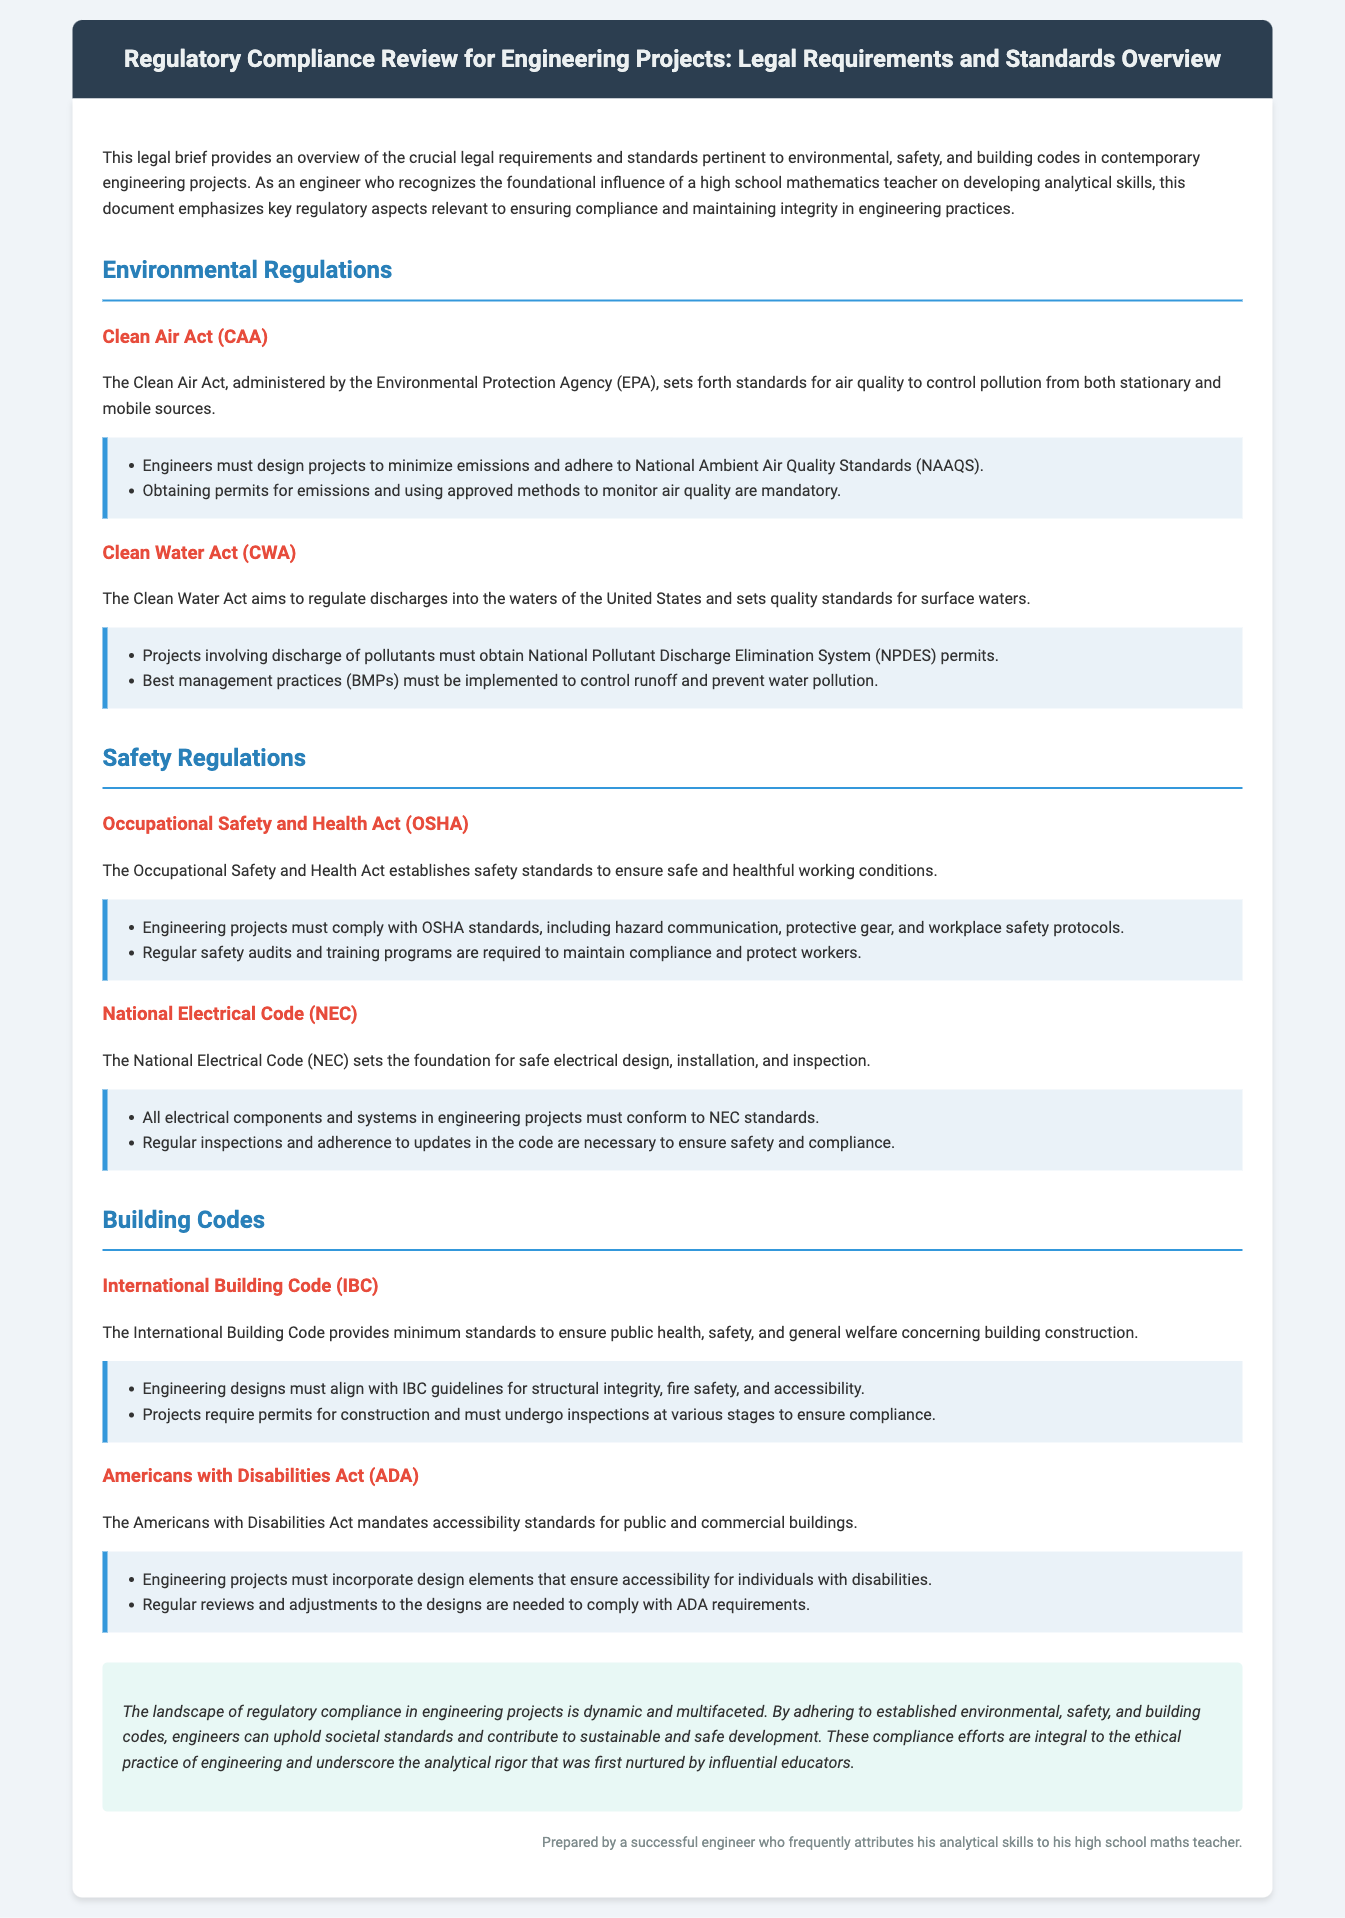What is the primary regulatory body for the Clean Air Act? The Clean Air Act is administered by the Environmental Protection Agency (EPA), which is the primary regulatory body overseeing its implementation.
Answer: Environmental Protection Agency (EPA) What must engineers obtain for discharges of pollutants? Engineers must obtain National Pollutant Discharge Elimination System (NPDES) permits for projects involving discharge of pollutants, as specified in the Clean Water Act section.
Answer: National Pollutant Discharge Elimination System (NPDES) permits What does OSHA stand for? OSHA stands for Occupational Safety and Health Act, a key regulation regarding workplace safety mentioned in the document.
Answer: Occupational Safety and Health Act Which code sets the standards for electrical systems in engineering projects? The National Electrical Code (NEC) establishes the standards for safe electrical design, installation, and inspection.
Answer: National Electrical Code (NEC) What does the Americans with Disabilities Act mandate? The Americans with Disabilities Act mandates accessibility standards for public and commercial buildings, ensuring inclusive design practices in engineering.
Answer: Accessibility standards How often should safety audits be conducted according to OSHA? Regular safety audits are required to maintain compliance and protect workers according to the standards of OSHA.
Answer: Regularly What is the purpose of the International Building Code? The International Building Code provides minimum standards to ensure public health, safety, and general welfare concerning building construction.
Answer: Minimum standards What is a requirement for construction projects according to IBC? Projects require permits for construction and must undergo inspections at various stages to ensure compliance with the International Building Code.
Answer: Permits for construction What element is crucial for controlling runoff as per the Clean Water Act? Best management practices (BMPs) must be implemented to control runoff and prevent water pollution as stated in the Clean Water Act section.
Answer: Best management practices (BMPs) 